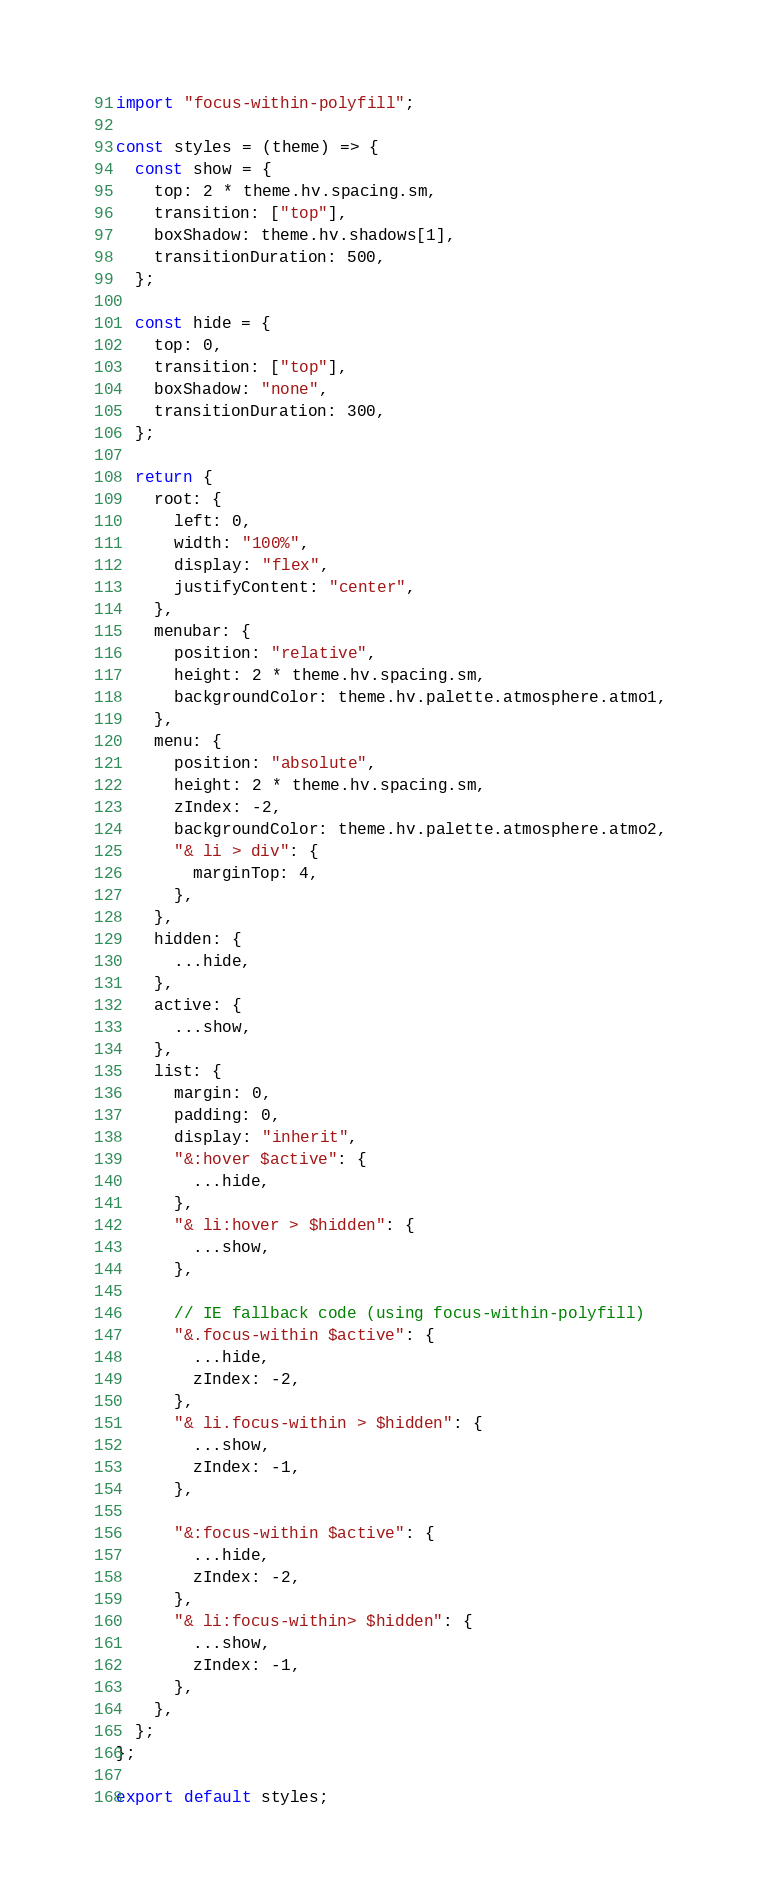Convert code to text. <code><loc_0><loc_0><loc_500><loc_500><_JavaScript_>import "focus-within-polyfill";

const styles = (theme) => {
  const show = {
    top: 2 * theme.hv.spacing.sm,
    transition: ["top"],
    boxShadow: theme.hv.shadows[1],
    transitionDuration: 500,
  };

  const hide = {
    top: 0,
    transition: ["top"],
    boxShadow: "none",
    transitionDuration: 300,
  };

  return {
    root: {
      left: 0,
      width: "100%",
      display: "flex",
      justifyContent: "center",
    },
    menubar: {
      position: "relative",
      height: 2 * theme.hv.spacing.sm,
      backgroundColor: theme.hv.palette.atmosphere.atmo1,
    },
    menu: {
      position: "absolute",
      height: 2 * theme.hv.spacing.sm,
      zIndex: -2,
      backgroundColor: theme.hv.palette.atmosphere.atmo2,
      "& li > div": {
        marginTop: 4,
      },
    },
    hidden: {
      ...hide,
    },
    active: {
      ...show,
    },
    list: {
      margin: 0,
      padding: 0,
      display: "inherit",
      "&:hover $active": {
        ...hide,
      },
      "& li:hover > $hidden": {
        ...show,
      },

      // IE fallback code (using focus-within-polyfill)
      "&.focus-within $active": {
        ...hide,
        zIndex: -2,
      },
      "& li.focus-within > $hidden": {
        ...show,
        zIndex: -1,
      },

      "&:focus-within $active": {
        ...hide,
        zIndex: -2,
      },
      "& li:focus-within> $hidden": {
        ...show,
        zIndex: -1,
      },
    },
  };
};

export default styles;
</code> 